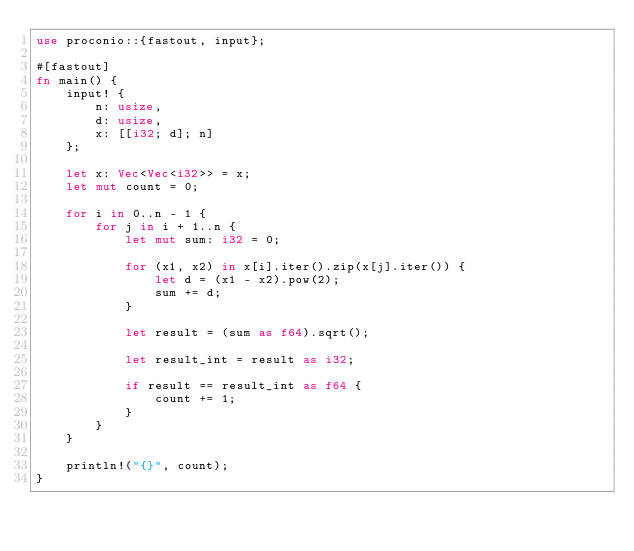<code> <loc_0><loc_0><loc_500><loc_500><_Rust_>use proconio::{fastout, input};

#[fastout]
fn main() {
    input! {
        n: usize,
        d: usize,
        x: [[i32; d]; n]
    };

    let x: Vec<Vec<i32>> = x;
    let mut count = 0;

    for i in 0..n - 1 {
        for j in i + 1..n {
            let mut sum: i32 = 0;

            for (x1, x2) in x[i].iter().zip(x[j].iter()) {
                let d = (x1 - x2).pow(2);
                sum += d;
            }

            let result = (sum as f64).sqrt();

            let result_int = result as i32;

            if result == result_int as f64 {
                count += 1;
            }
        }
    }

    println!("{}", count);
}
</code> 